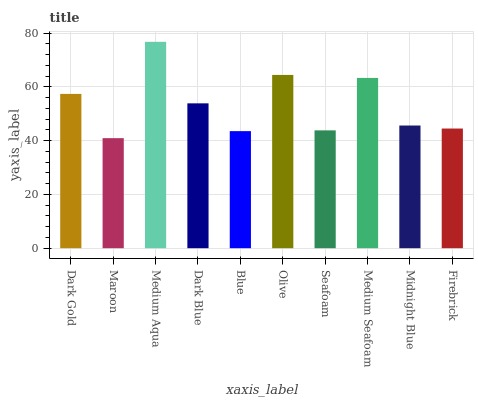Is Maroon the minimum?
Answer yes or no. Yes. Is Medium Aqua the maximum?
Answer yes or no. Yes. Is Medium Aqua the minimum?
Answer yes or no. No. Is Maroon the maximum?
Answer yes or no. No. Is Medium Aqua greater than Maroon?
Answer yes or no. Yes. Is Maroon less than Medium Aqua?
Answer yes or no. Yes. Is Maroon greater than Medium Aqua?
Answer yes or no. No. Is Medium Aqua less than Maroon?
Answer yes or no. No. Is Dark Blue the high median?
Answer yes or no. Yes. Is Midnight Blue the low median?
Answer yes or no. Yes. Is Blue the high median?
Answer yes or no. No. Is Firebrick the low median?
Answer yes or no. No. 